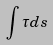<formula> <loc_0><loc_0><loc_500><loc_500>\int { { \tau } d s }</formula> 